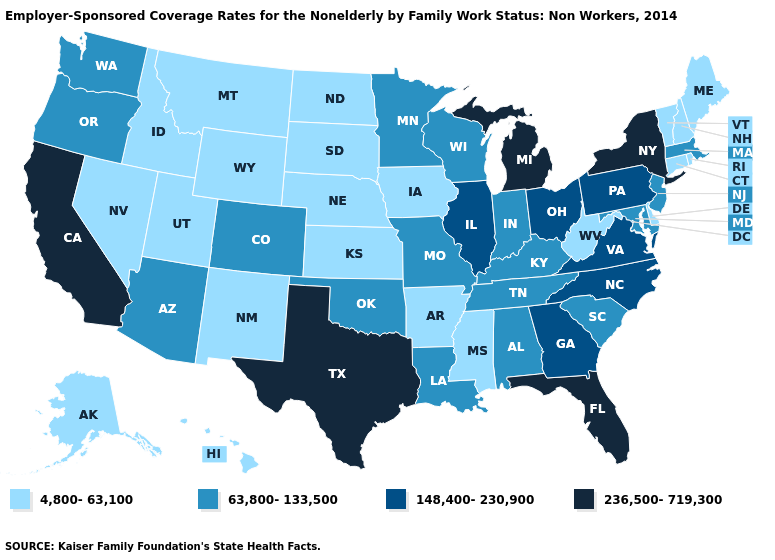Does Michigan have the highest value in the USA?
Be succinct. Yes. Name the states that have a value in the range 236,500-719,300?
Short answer required. California, Florida, Michigan, New York, Texas. Which states have the lowest value in the MidWest?
Short answer required. Iowa, Kansas, Nebraska, North Dakota, South Dakota. Among the states that border Missouri , does Kansas have the highest value?
Write a very short answer. No. Which states have the lowest value in the USA?
Be succinct. Alaska, Arkansas, Connecticut, Delaware, Hawaii, Idaho, Iowa, Kansas, Maine, Mississippi, Montana, Nebraska, Nevada, New Hampshire, New Mexico, North Dakota, Rhode Island, South Dakota, Utah, Vermont, West Virginia, Wyoming. Name the states that have a value in the range 236,500-719,300?
Answer briefly. California, Florida, Michigan, New York, Texas. Does the map have missing data?
Give a very brief answer. No. What is the value of Kentucky?
Give a very brief answer. 63,800-133,500. What is the value of Georgia?
Answer briefly. 148,400-230,900. Does Alaska have the lowest value in the West?
Be succinct. Yes. Does the map have missing data?
Answer briefly. No. Among the states that border Nevada , which have the highest value?
Answer briefly. California. What is the highest value in the South ?
Be succinct. 236,500-719,300. What is the value of Louisiana?
Concise answer only. 63,800-133,500. Does Oklahoma have the same value as Colorado?
Answer briefly. Yes. 